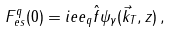<formula> <loc_0><loc_0><loc_500><loc_500>F _ { e s } ^ { q } ( 0 ) = i e e _ { q } \hat { f } \psi _ { \gamma } ( \vec { k } _ { T } , z ) \, ,</formula> 